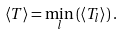<formula> <loc_0><loc_0><loc_500><loc_500>\left \langle T \right \rangle = \min _ { l } \left ( \left \langle T _ { l } \right \rangle \right ) .</formula> 